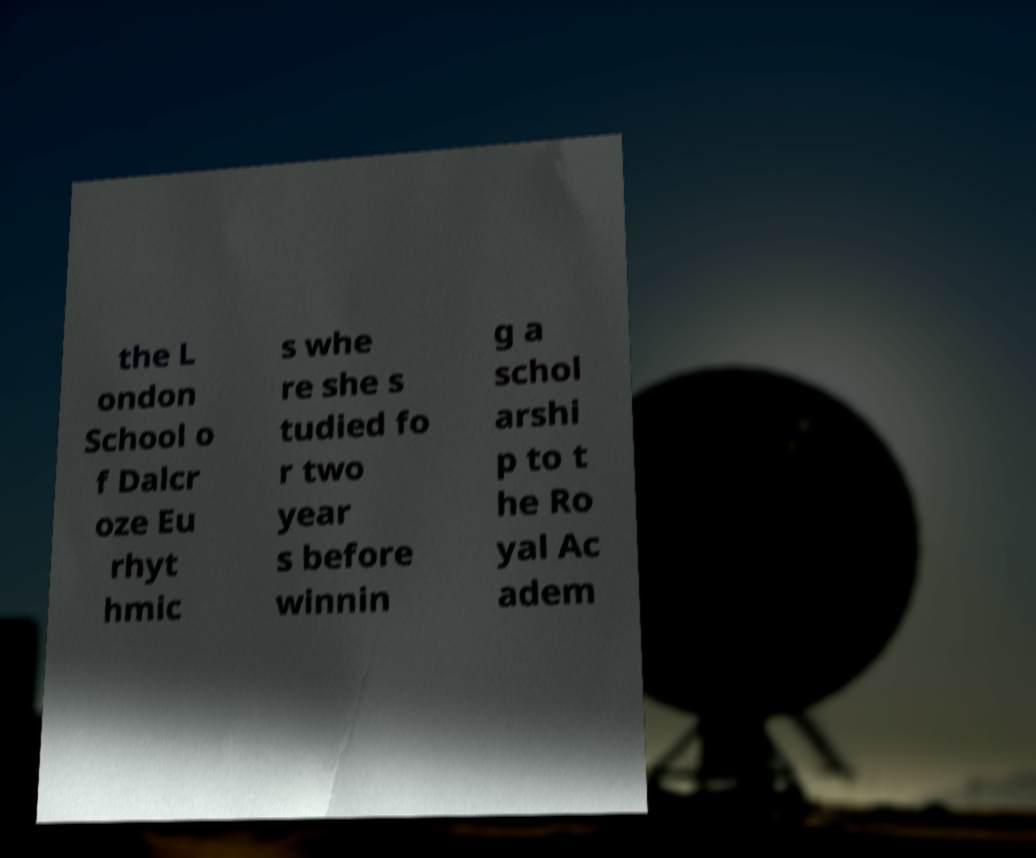Can you read and provide the text displayed in the image?This photo seems to have some interesting text. Can you extract and type it out for me? the L ondon School o f Dalcr oze Eu rhyt hmic s whe re she s tudied fo r two year s before winnin g a schol arshi p to t he Ro yal Ac adem 